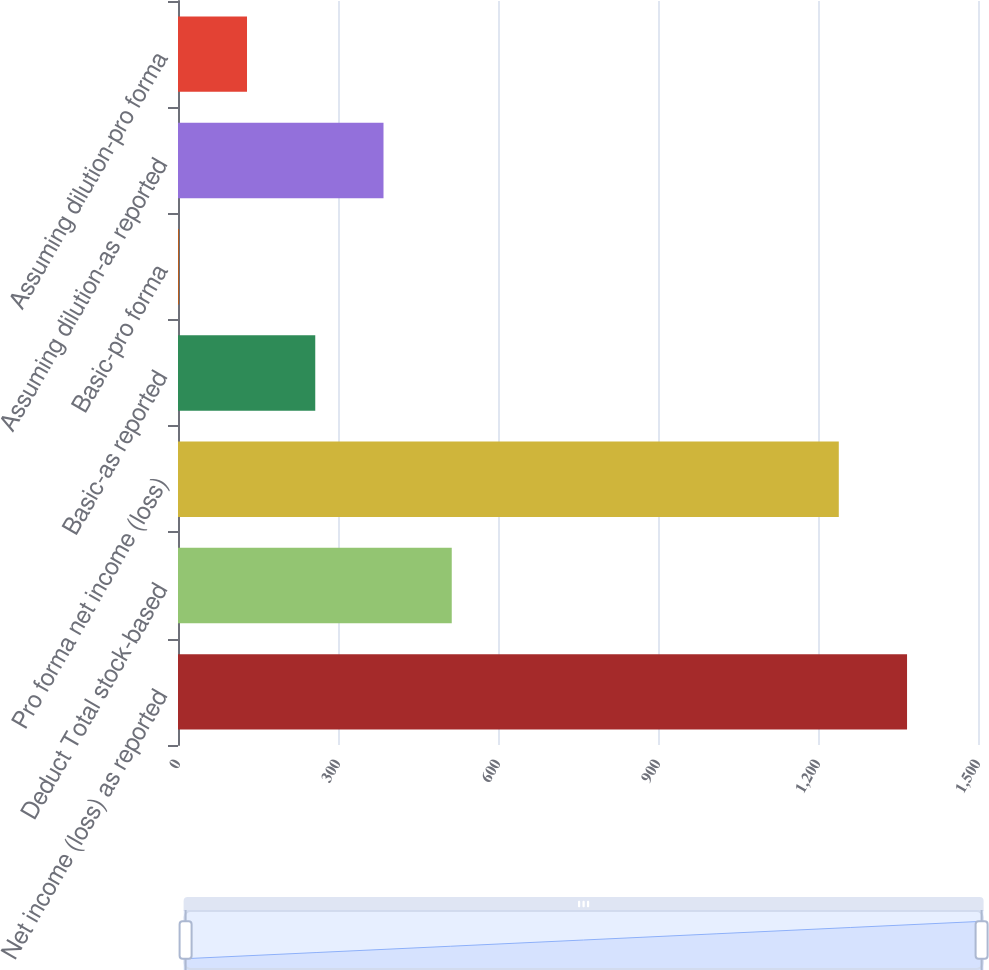<chart> <loc_0><loc_0><loc_500><loc_500><bar_chart><fcel>Net income (loss) as reported<fcel>Deduct Total stock-based<fcel>Pro forma net income (loss)<fcel>Basic-as reported<fcel>Basic-pro forma<fcel>Assuming dilution-as reported<fcel>Assuming dilution-pro forma<nl><fcel>1366.96<fcel>513.28<fcel>1239<fcel>257.36<fcel>1.44<fcel>385.32<fcel>129.4<nl></chart> 